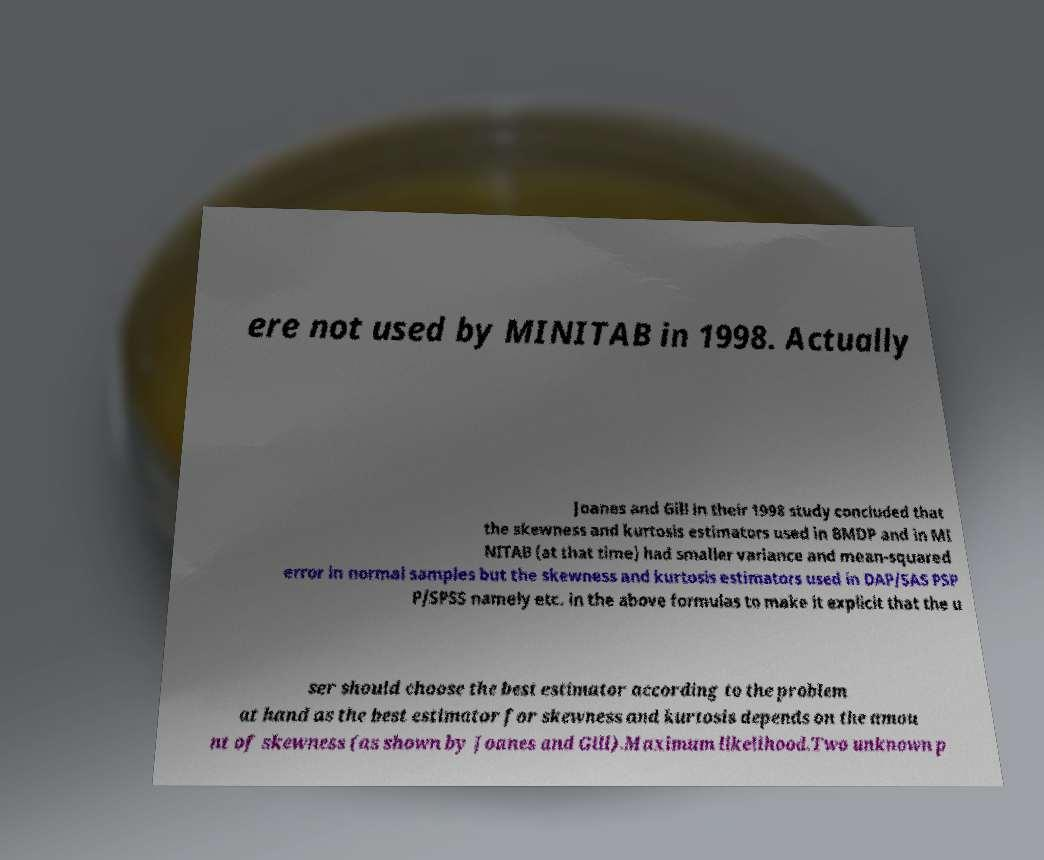Can you read and provide the text displayed in the image?This photo seems to have some interesting text. Can you extract and type it out for me? ere not used by MINITAB in 1998. Actually Joanes and Gill in their 1998 study concluded that the skewness and kurtosis estimators used in BMDP and in MI NITAB (at that time) had smaller variance and mean-squared error in normal samples but the skewness and kurtosis estimators used in DAP/SAS PSP P/SPSS namely etc. in the above formulas to make it explicit that the u ser should choose the best estimator according to the problem at hand as the best estimator for skewness and kurtosis depends on the amou nt of skewness (as shown by Joanes and Gill).Maximum likelihood.Two unknown p 